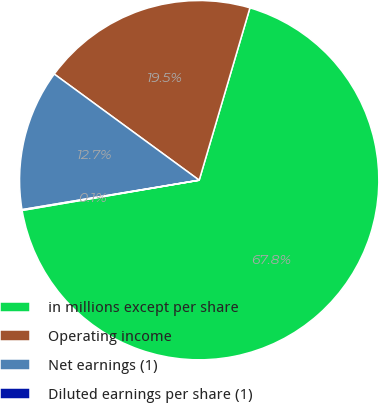Convert chart. <chart><loc_0><loc_0><loc_500><loc_500><pie_chart><fcel>in millions except per share<fcel>Operating income<fcel>Net earnings (1)<fcel>Diluted earnings per share (1)<nl><fcel>67.75%<fcel>19.5%<fcel>12.68%<fcel>0.07%<nl></chart> 